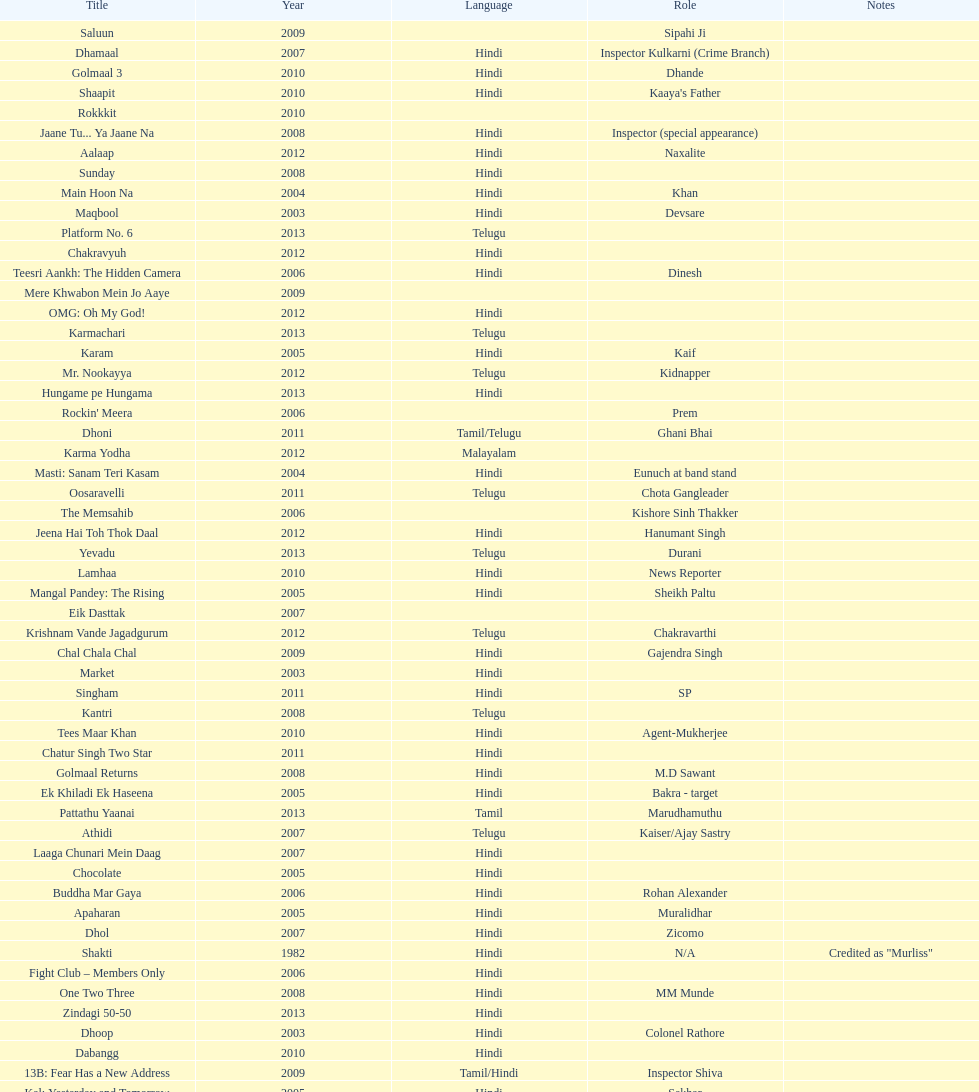Give me the full table as a dictionary. {'header': ['Title', 'Year', 'Language', 'Role', 'Notes'], 'rows': [['Saluun', '2009', '', 'Sipahi Ji', ''], ['Dhamaal', '2007', 'Hindi', 'Inspector Kulkarni (Crime Branch)', ''], ['Golmaal 3', '2010', 'Hindi', 'Dhande', ''], ['Shaapit', '2010', 'Hindi', "Kaaya's Father", ''], ['Rokkkit', '2010', '', '', ''], ['Jaane Tu... Ya Jaane Na', '2008', 'Hindi', 'Inspector (special appearance)', ''], ['Aalaap', '2012', 'Hindi', 'Naxalite', ''], ['Sunday', '2008', 'Hindi', '', ''], ['Main Hoon Na', '2004', 'Hindi', 'Khan', ''], ['Maqbool', '2003', 'Hindi', 'Devsare', ''], ['Platform No. 6', '2013', 'Telugu', '', ''], ['Chakravyuh', '2012', 'Hindi', '', ''], ['Teesri Aankh: The Hidden Camera', '2006', 'Hindi', 'Dinesh', ''], ['Mere Khwabon Mein Jo Aaye', '2009', '', '', ''], ['OMG: Oh My God!', '2012', 'Hindi', '', ''], ['Karmachari', '2013', 'Telugu', '', ''], ['Karam', '2005', 'Hindi', 'Kaif', ''], ['Mr. Nookayya', '2012', 'Telugu', 'Kidnapper', ''], ['Hungame pe Hungama', '2013', 'Hindi', '', ''], ["Rockin' Meera", '2006', '', 'Prem', ''], ['Dhoni', '2011', 'Tamil/Telugu', 'Ghani Bhai', ''], ['Karma Yodha', '2012', 'Malayalam', '', ''], ['Masti: Sanam Teri Kasam', '2004', 'Hindi', 'Eunuch at band stand', ''], ['Oosaravelli', '2011', 'Telugu', 'Chota Gangleader', ''], ['The Memsahib', '2006', '', 'Kishore Sinh Thakker', ''], ['Jeena Hai Toh Thok Daal', '2012', 'Hindi', 'Hanumant Singh', ''], ['Yevadu', '2013', 'Telugu', 'Durani', ''], ['Lamhaa', '2010', 'Hindi', 'News Reporter', ''], ['Mangal Pandey: The Rising', '2005', 'Hindi', 'Sheikh Paltu', ''], ['Eik Dasttak', '2007', '', '', ''], ['Krishnam Vande Jagadgurum', '2012', 'Telugu', 'Chakravarthi', ''], ['Chal Chala Chal', '2009', 'Hindi', 'Gajendra Singh', ''], ['Market', '2003', 'Hindi', '', ''], ['Singham', '2011', 'Hindi', 'SP', ''], ['Kantri', '2008', 'Telugu', '', ''], ['Tees Maar Khan', '2010', 'Hindi', 'Agent-Mukherjee', ''], ['Chatur Singh Two Star', '2011', 'Hindi', '', ''], ['Golmaal Returns', '2008', 'Hindi', 'M.D Sawant', ''], ['Ek Khiladi Ek Haseena', '2005', 'Hindi', 'Bakra - target', ''], ['Pattathu Yaanai', '2013', 'Tamil', 'Marudhamuthu', ''], ['Athidi', '2007', 'Telugu', 'Kaiser/Ajay Sastry', ''], ['Laaga Chunari Mein Daag', '2007', 'Hindi', '', ''], ['Chocolate', '2005', 'Hindi', '', ''], ['Buddha Mar Gaya', '2006', 'Hindi', 'Rohan Alexander', ''], ['Apaharan', '2005', 'Hindi', 'Muralidhar', ''], ['Dhol', '2007', 'Hindi', 'Zicomo', ''], ['Shakti', '1982', 'Hindi', 'N/A', 'Credited as "Murliss"'], ['Fight Club – Members Only', '2006', 'Hindi', '', ''], ['One Two Three', '2008', 'Hindi', 'MM Munde', ''], ['Zindagi 50-50', '2013', 'Hindi', '', ''], ['Dhoop', '2003', 'Hindi', 'Colonel Rathore', ''], ['Dabangg', '2010', 'Hindi', '', ''], ['13B: Fear Has a New Address', '2009', 'Tamil/Hindi', 'Inspector Shiva', ''], ['Kal: Yesterday and Tomorrow', '2005', 'Hindi', 'Sekhar', ''], ['Black Friday', '2004', 'Hindi', '', ''], ['Dil Vil Pyar Vyar', '2002', 'Hindi', 'N/A', ''], ['Choron Ki Baraat', '2012', 'Hindi', 'Tejeshwar Singh', '']]} How many roles has this actor had? 36. 